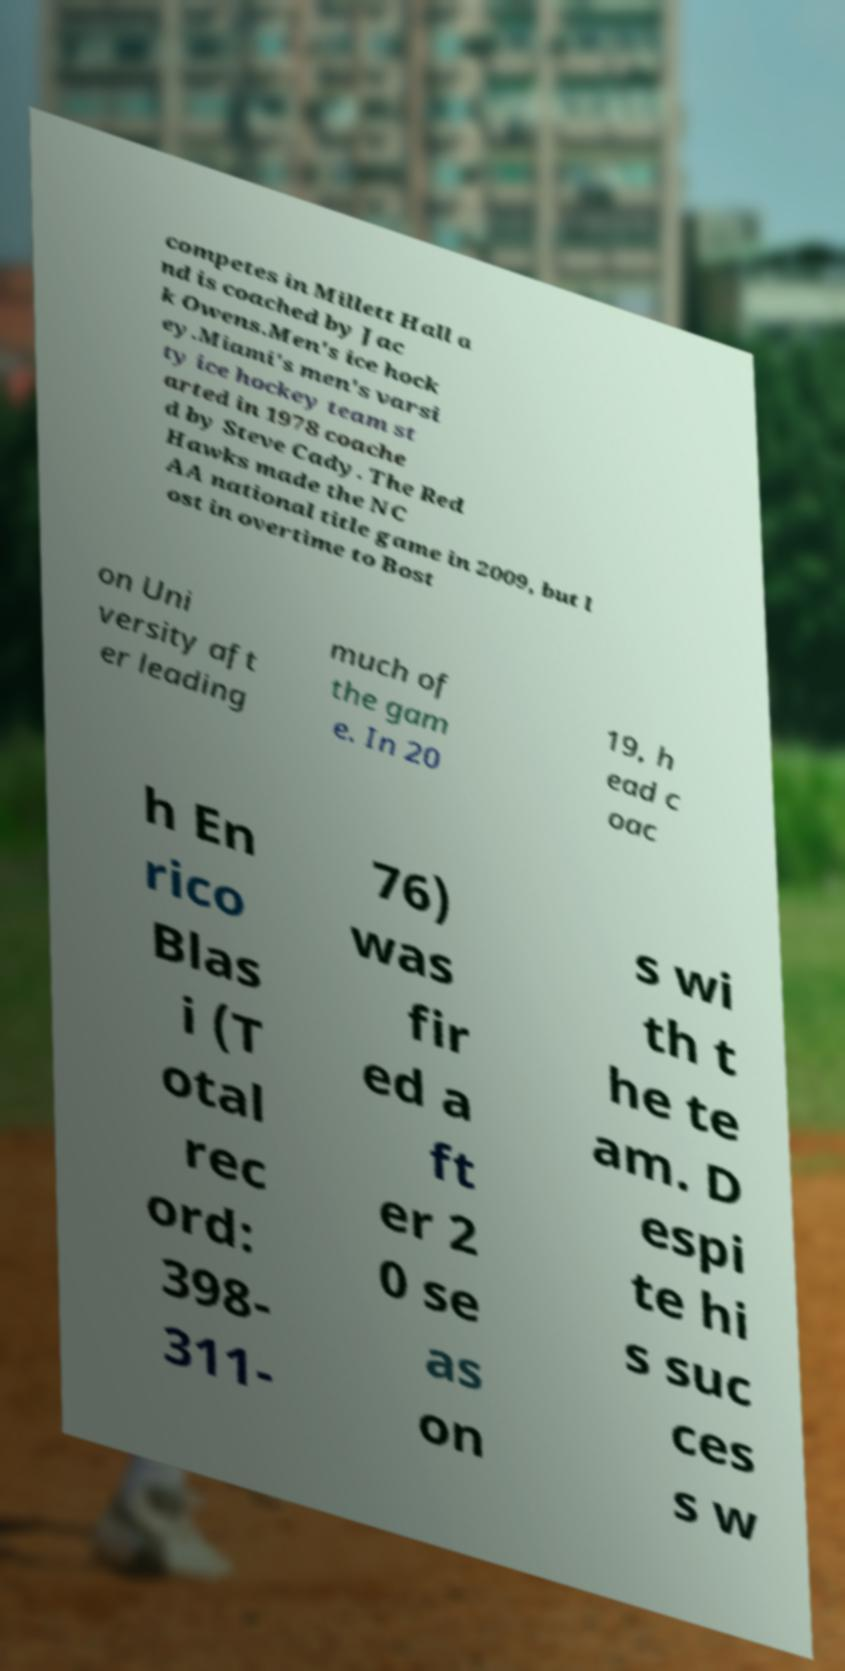For documentation purposes, I need the text within this image transcribed. Could you provide that? competes in Millett Hall a nd is coached by Jac k Owens.Men's ice hock ey.Miami's men's varsi ty ice hockey team st arted in 1978 coache d by Steve Cady. The Red Hawks made the NC AA national title game in 2009, but l ost in overtime to Bost on Uni versity aft er leading much of the gam e. In 20 19, h ead c oac h En rico Blas i (T otal rec ord: 398- 311- 76) was fir ed a ft er 2 0 se as on s wi th t he te am. D espi te hi s suc ces s w 